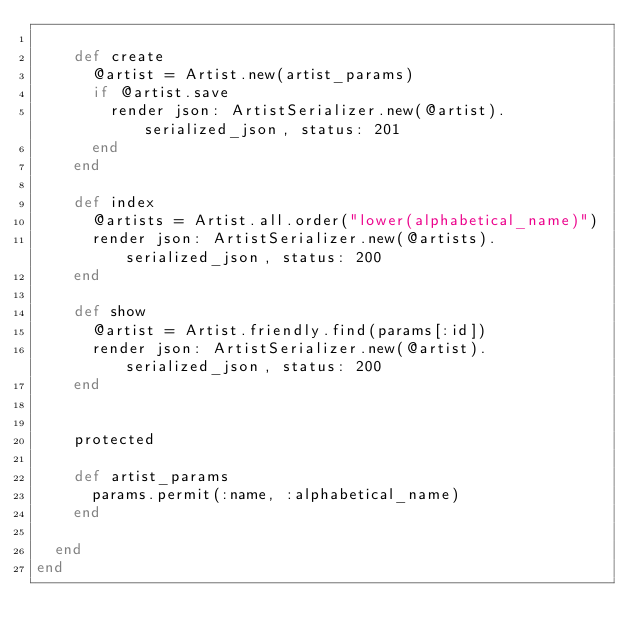Convert code to text. <code><loc_0><loc_0><loc_500><loc_500><_Ruby_>
    def create
      @artist = Artist.new(artist_params)
      if @artist.save
        render json: ArtistSerializer.new(@artist).serialized_json, status: 201
      end
    end
    
    def index
      @artists = Artist.all.order("lower(alphabetical_name)")
      render json: ArtistSerializer.new(@artists).serialized_json, status: 200
    end

    def show
      @artist = Artist.friendly.find(params[:id])
      render json: ArtistSerializer.new(@artist).serialized_json, status: 200
    end
    

    protected

    def artist_params
      params.permit(:name, :alphabetical_name)
    end
    
  end
end
    </code> 